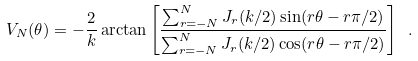Convert formula to latex. <formula><loc_0><loc_0><loc_500><loc_500>V _ { N } ( \theta ) = - \frac { 2 } { k } \arctan \left [ \frac { \sum _ { r = - N } ^ { N } J _ { r } ( k / 2 ) \sin ( r \theta - r \pi / 2 ) } { \sum _ { r = - N } ^ { N } J _ { r } ( k / 2 ) \cos ( r \theta - r \pi / 2 ) } \right ] \ .</formula> 